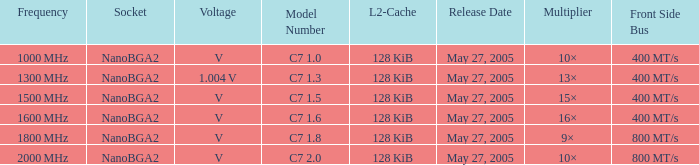What is the launch date for model number c7 May 27, 2005. 